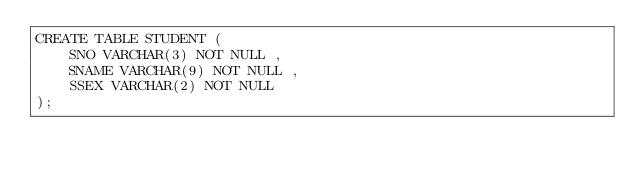Convert code to text. <code><loc_0><loc_0><loc_500><loc_500><_SQL_>CREATE TABLE STUDENT (
    SNO VARCHAR(3) NOT NULL ,
    SNAME VARCHAR(9) NOT NULL ,
    SSEX VARCHAR(2) NOT NULL
);</code> 